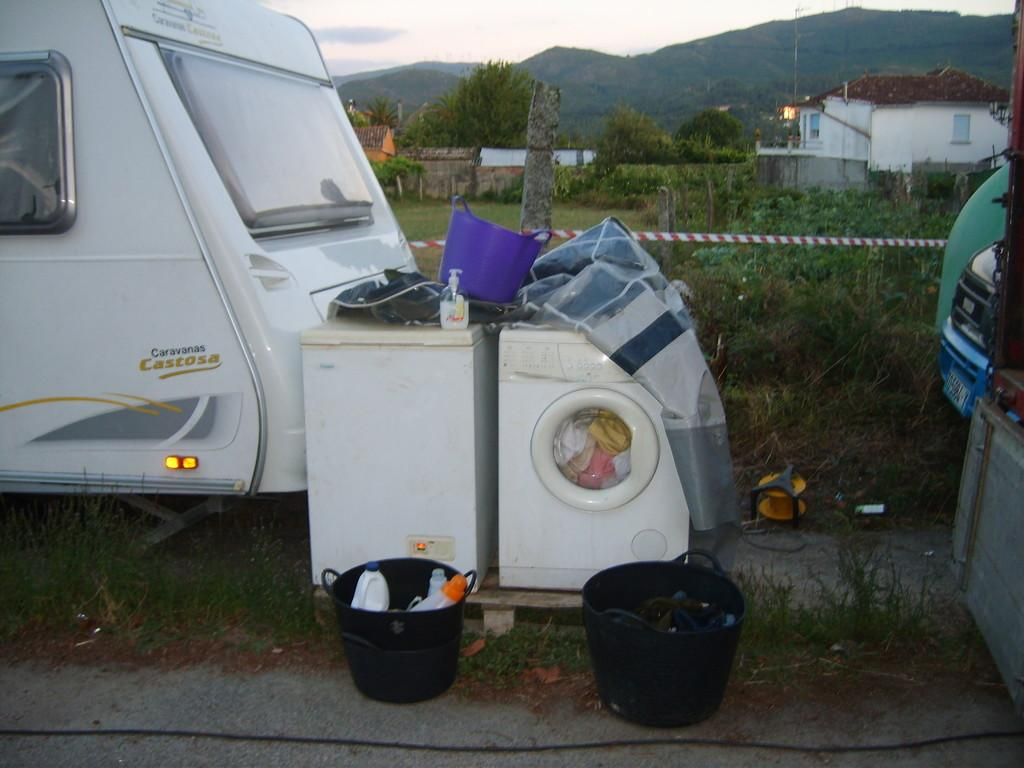What types of objects can be seen in the image? There are vehicles, a washing machine, buckets, bottles, and a basket in the image. What can be found inside the basket? Clothes can be found inside the basket. What is the natural environment visible in the image? There is grass, plants, trees, and sky visible in the image. What structures can be seen in the background of the image? There are houses, trees, and poles in the background of the image. Where is the cellar located in the image? There is no cellar present in the image. What type of appliance is being used to clean the feet in the image? There is no appliance or feet cleaning activity depicted in the image. 